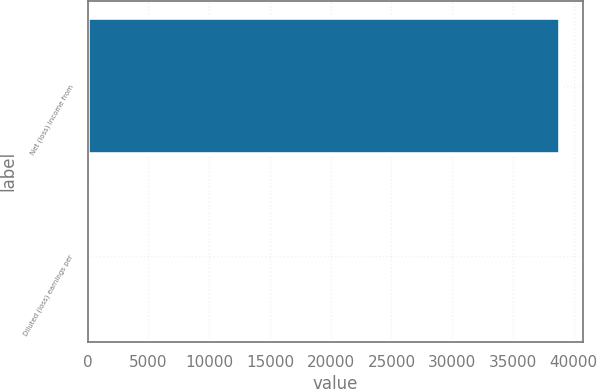Convert chart. <chart><loc_0><loc_0><loc_500><loc_500><bar_chart><fcel>Net (loss) income from<fcel>Diluted (loss) earnings per<nl><fcel>38843<fcel>0.1<nl></chart> 